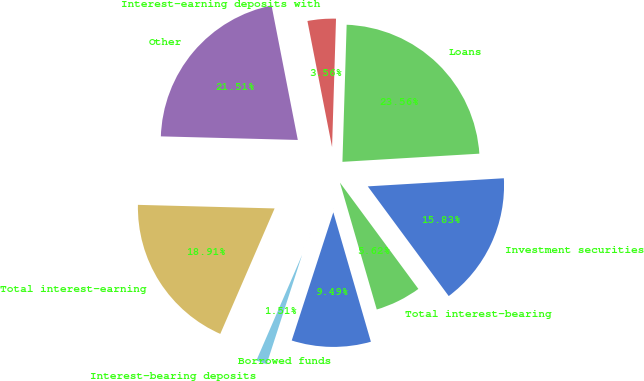Convert chart. <chart><loc_0><loc_0><loc_500><loc_500><pie_chart><fcel>Investment securities<fcel>Loans<fcel>Interest-earning deposits with<fcel>Other<fcel>Total interest-earning<fcel>Interest-bearing deposits<fcel>Borrowed funds<fcel>Total interest-bearing<nl><fcel>15.83%<fcel>23.56%<fcel>3.56%<fcel>21.51%<fcel>18.91%<fcel>1.51%<fcel>9.49%<fcel>5.62%<nl></chart> 